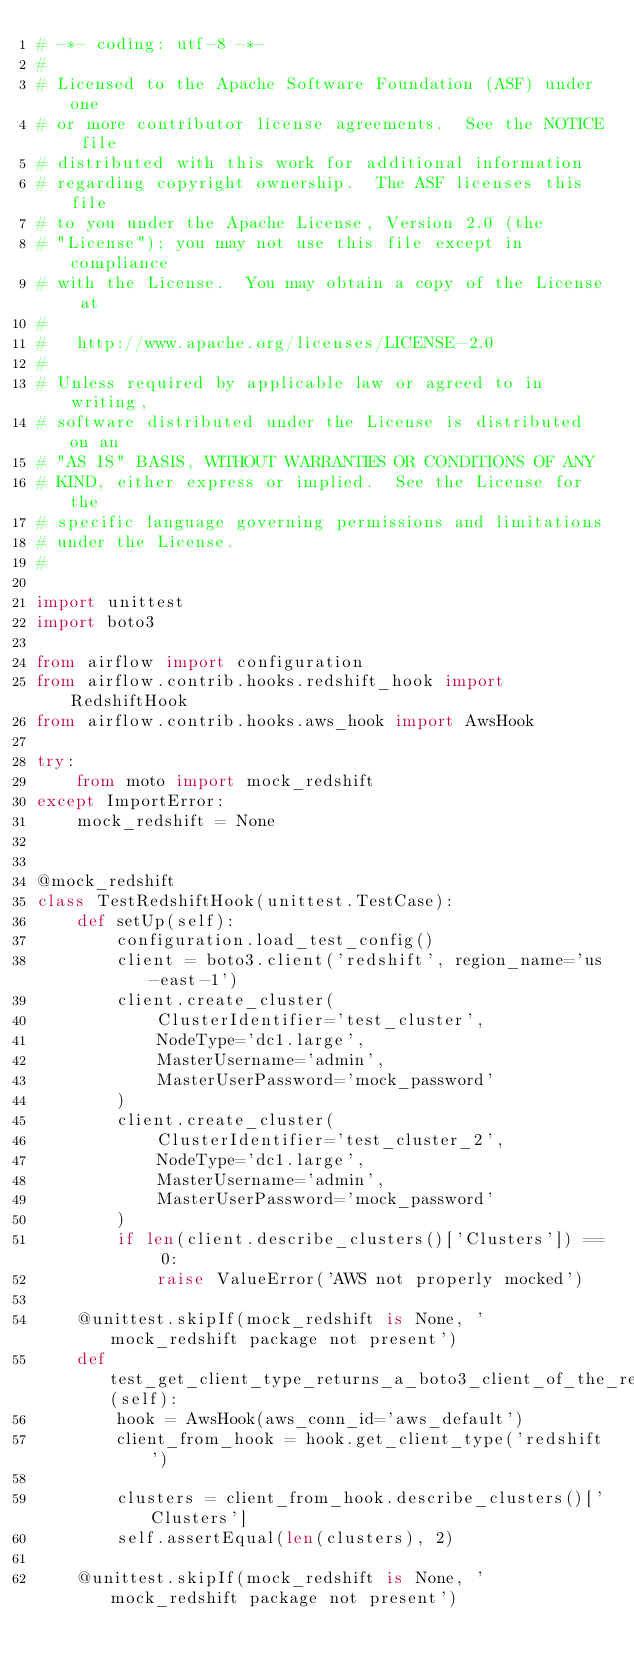<code> <loc_0><loc_0><loc_500><loc_500><_Python_># -*- coding: utf-8 -*-
#
# Licensed to the Apache Software Foundation (ASF) under one
# or more contributor license agreements.  See the NOTICE file
# distributed with this work for additional information
# regarding copyright ownership.  The ASF licenses this file
# to you under the Apache License, Version 2.0 (the
# "License"); you may not use this file except in compliance
# with the License.  You may obtain a copy of the License at
# 
#   http://www.apache.org/licenses/LICENSE-2.0
# 
# Unless required by applicable law or agreed to in writing,
# software distributed under the License is distributed on an
# "AS IS" BASIS, WITHOUT WARRANTIES OR CONDITIONS OF ANY
# KIND, either express or implied.  See the License for the
# specific language governing permissions and limitations
# under the License.
#

import unittest
import boto3

from airflow import configuration
from airflow.contrib.hooks.redshift_hook import RedshiftHook
from airflow.contrib.hooks.aws_hook import AwsHook

try:
    from moto import mock_redshift
except ImportError:
    mock_redshift = None


@mock_redshift
class TestRedshiftHook(unittest.TestCase):
    def setUp(self):
        configuration.load_test_config()
        client = boto3.client('redshift', region_name='us-east-1')
        client.create_cluster(
            ClusterIdentifier='test_cluster',
            NodeType='dc1.large',
            MasterUsername='admin',
            MasterUserPassword='mock_password'
        )
        client.create_cluster(
            ClusterIdentifier='test_cluster_2',
            NodeType='dc1.large',
            MasterUsername='admin',
            MasterUserPassword='mock_password'
        )
        if len(client.describe_clusters()['Clusters']) == 0:
            raise ValueError('AWS not properly mocked')

    @unittest.skipIf(mock_redshift is None, 'mock_redshift package not present')
    def test_get_client_type_returns_a_boto3_client_of_the_requested_type(self):
        hook = AwsHook(aws_conn_id='aws_default')
        client_from_hook = hook.get_client_type('redshift')

        clusters = client_from_hook.describe_clusters()['Clusters']
        self.assertEqual(len(clusters), 2)

    @unittest.skipIf(mock_redshift is None, 'mock_redshift package not present')</code> 